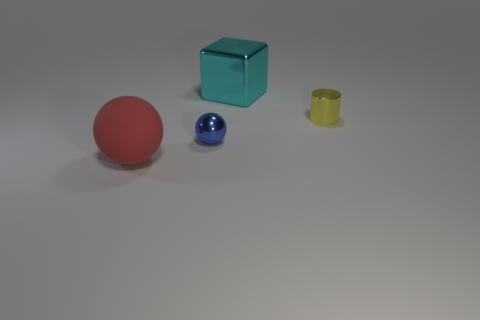Add 4 small gray rubber cubes. How many objects exist? 8 Subtract all cylinders. How many objects are left? 3 Subtract all cyan blocks. Subtract all small blue things. How many objects are left? 2 Add 4 large metallic blocks. How many large metallic blocks are left? 5 Add 3 big yellow objects. How many big yellow objects exist? 3 Subtract 0 brown cubes. How many objects are left? 4 